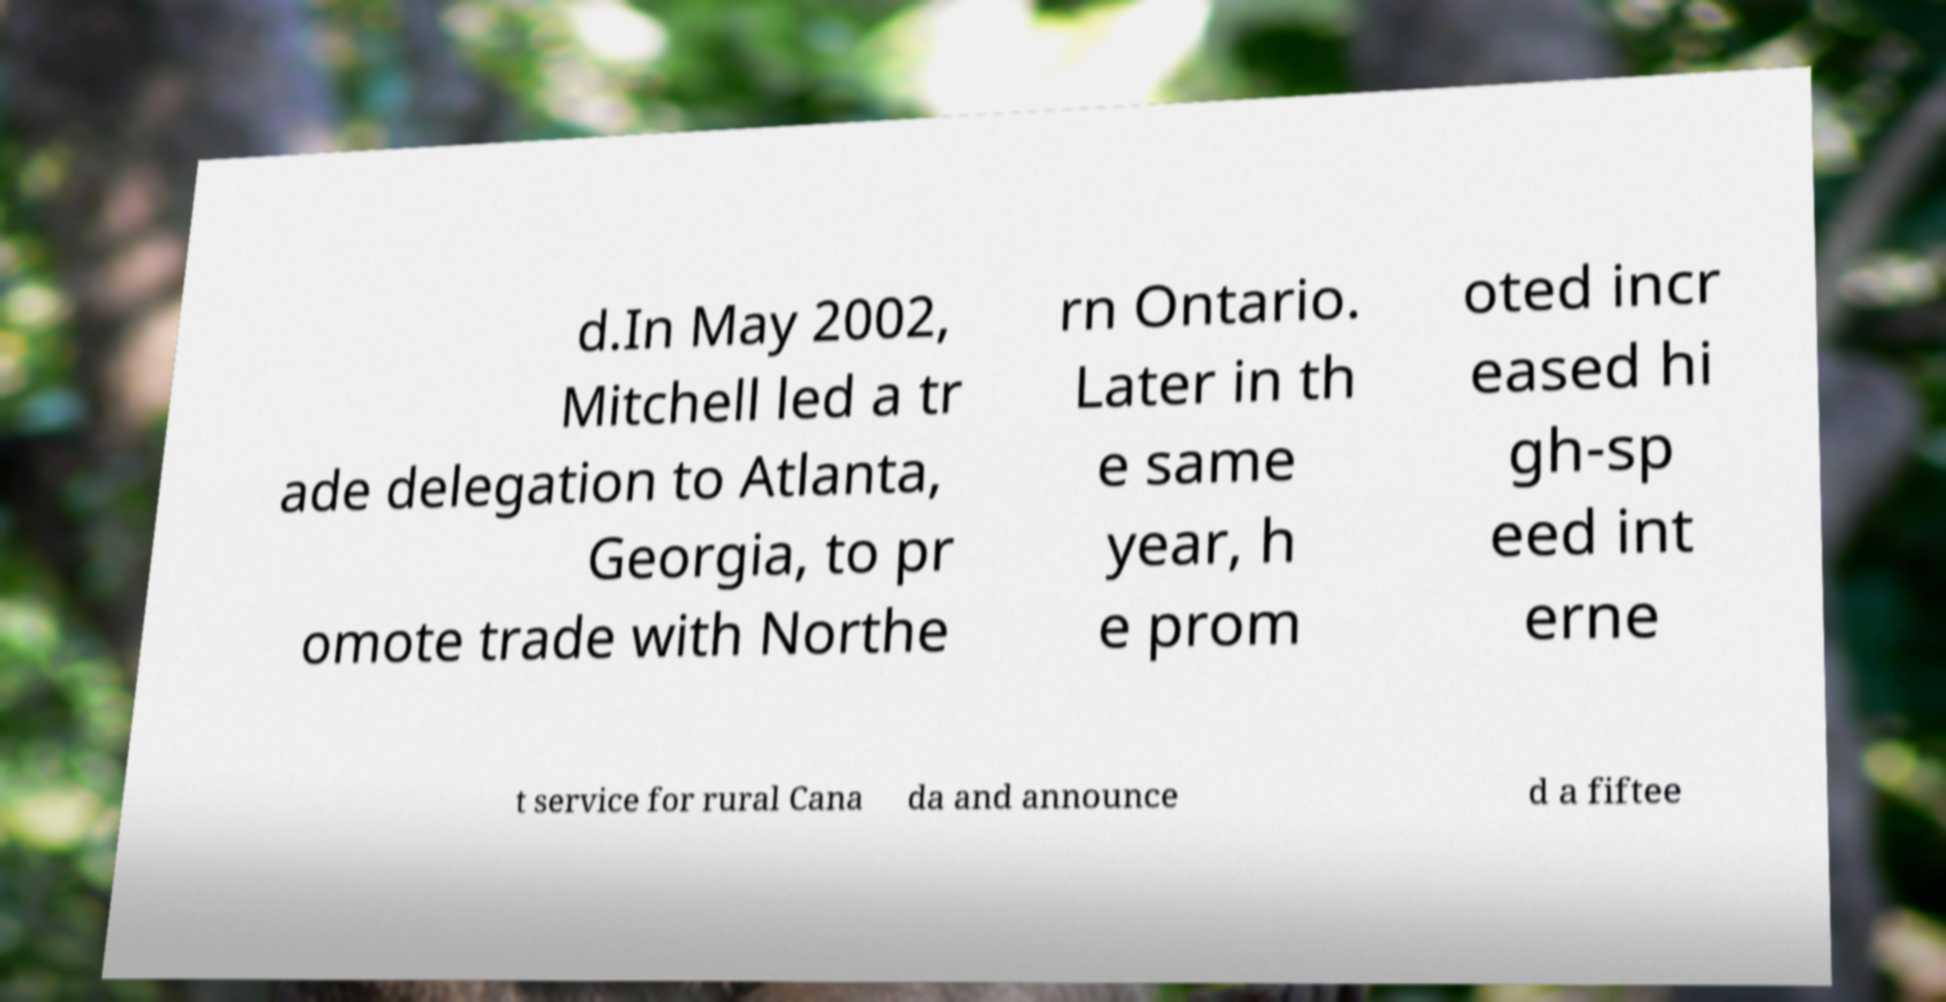What messages or text are displayed in this image? I need them in a readable, typed format. d.In May 2002, Mitchell led a tr ade delegation to Atlanta, Georgia, to pr omote trade with Northe rn Ontario. Later in th e same year, h e prom oted incr eased hi gh-sp eed int erne t service for rural Cana da and announce d a fiftee 